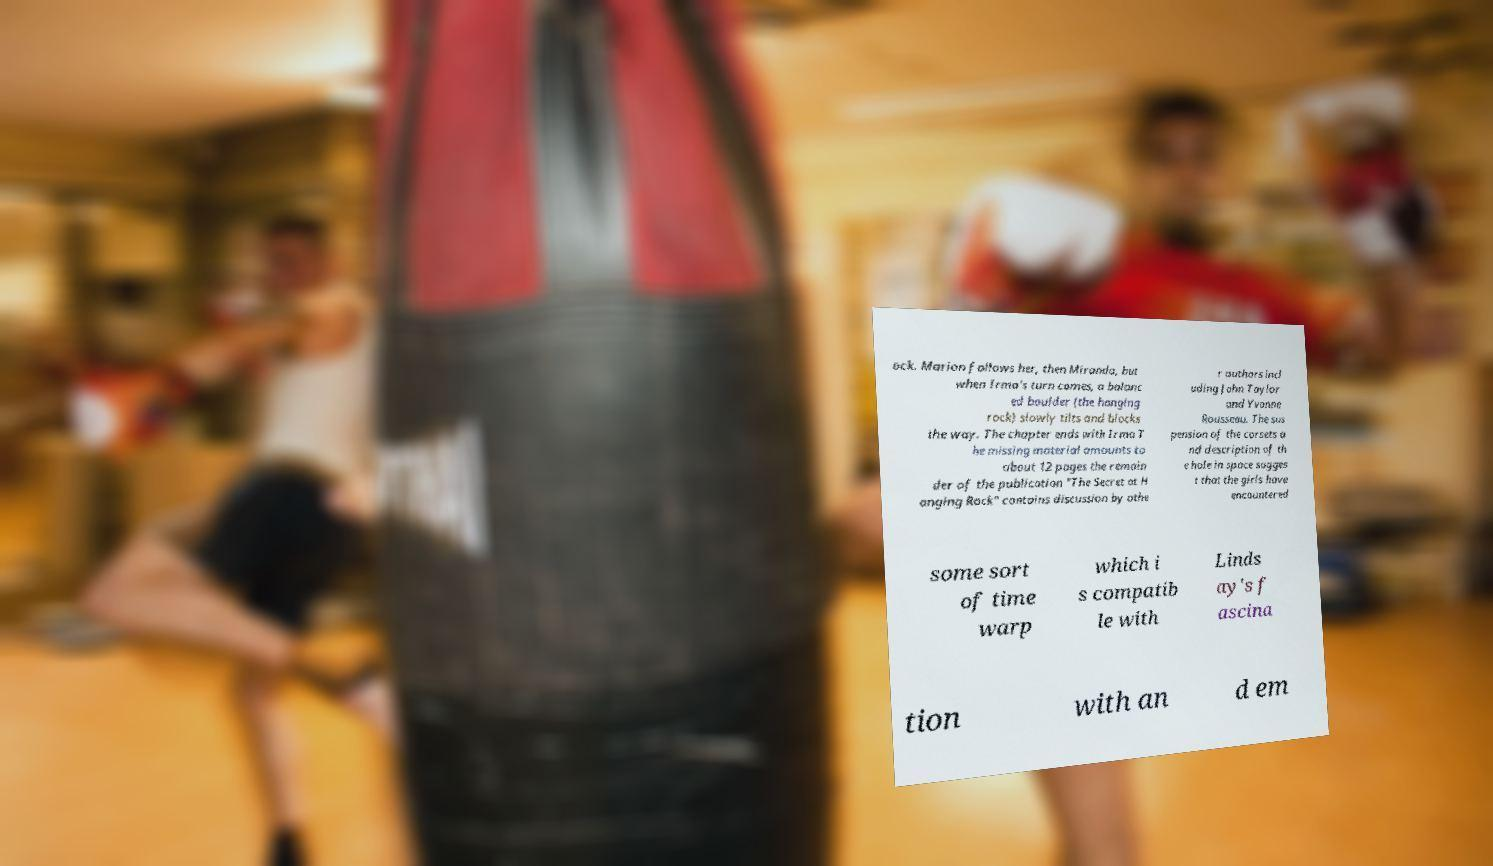Could you extract and type out the text from this image? ock. Marion follows her, then Miranda, but when Irma's turn comes, a balanc ed boulder (the hanging rock) slowly tilts and blocks the way. The chapter ends with Irma T he missing material amounts to about 12 pages the remain der of the publication "The Secret at H anging Rock" contains discussion by othe r authors incl uding John Taylor and Yvonne Rousseau. The sus pension of the corsets a nd description of th e hole in space sugges t that the girls have encountered some sort of time warp which i s compatib le with Linds ay's f ascina tion with an d em 